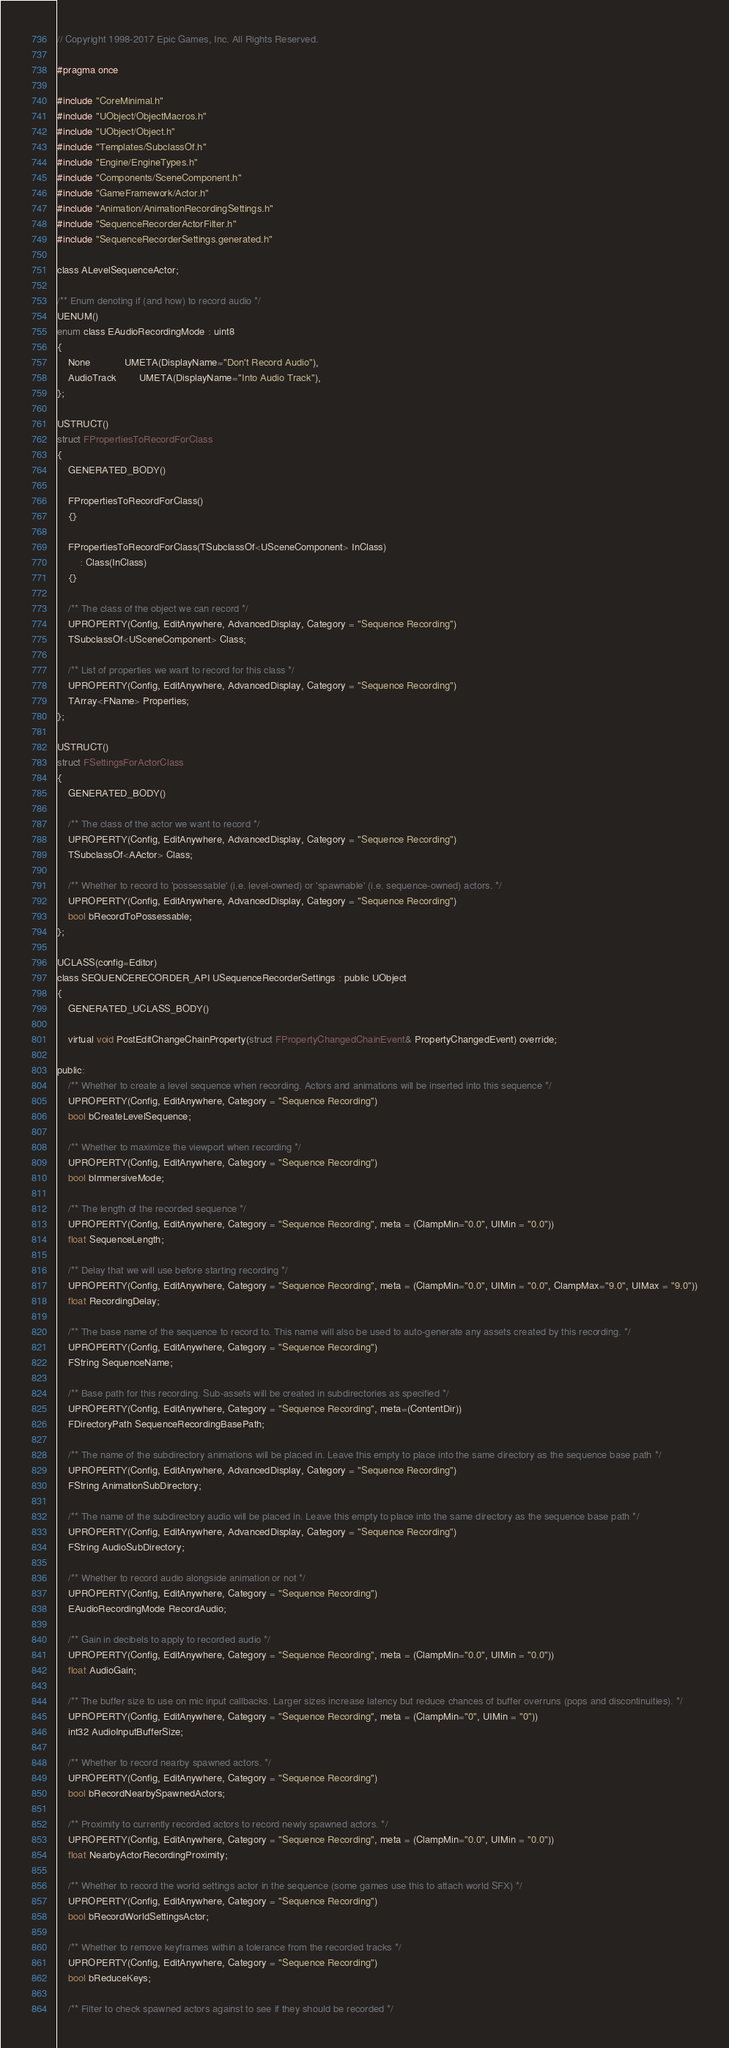<code> <loc_0><loc_0><loc_500><loc_500><_C_>// Copyright 1998-2017 Epic Games, Inc. All Rights Reserved.

#pragma once

#include "CoreMinimal.h"
#include "UObject/ObjectMacros.h"
#include "UObject/Object.h"
#include "Templates/SubclassOf.h"
#include "Engine/EngineTypes.h"
#include "Components/SceneComponent.h"
#include "GameFramework/Actor.h"
#include "Animation/AnimationRecordingSettings.h"
#include "SequenceRecorderActorFilter.h"
#include "SequenceRecorderSettings.generated.h"

class ALevelSequenceActor;

/** Enum denoting if (and how) to record audio */
UENUM()
enum class EAudioRecordingMode : uint8
{
	None 			UMETA(DisplayName="Don't Record Audio"),
	AudioTrack		UMETA(DisplayName="Into Audio Track"),
};

USTRUCT()
struct FPropertiesToRecordForClass
{
	GENERATED_BODY()

	FPropertiesToRecordForClass()
	{}

	FPropertiesToRecordForClass(TSubclassOf<USceneComponent> InClass)
		: Class(InClass)
	{}

	/** The class of the object we can record */
	UPROPERTY(Config, EditAnywhere, AdvancedDisplay, Category = "Sequence Recording")
	TSubclassOf<USceneComponent> Class;

	/** List of properties we want to record for this class */
	UPROPERTY(Config, EditAnywhere, AdvancedDisplay, Category = "Sequence Recording")
	TArray<FName> Properties;
};

USTRUCT()
struct FSettingsForActorClass
{
	GENERATED_BODY()

	/** The class of the actor we want to record */
	UPROPERTY(Config, EditAnywhere, AdvancedDisplay, Category = "Sequence Recording")
	TSubclassOf<AActor> Class;

	/** Whether to record to 'possessable' (i.e. level-owned) or 'spawnable' (i.e. sequence-owned) actors. */
	UPROPERTY(Config, EditAnywhere, AdvancedDisplay, Category = "Sequence Recording")
	bool bRecordToPossessable;
};

UCLASS(config=Editor)
class SEQUENCERECORDER_API USequenceRecorderSettings : public UObject
{
	GENERATED_UCLASS_BODY()

	virtual void PostEditChangeChainProperty(struct FPropertyChangedChainEvent& PropertyChangedEvent) override;

public:
	/** Whether to create a level sequence when recording. Actors and animations will be inserted into this sequence */
	UPROPERTY(Config, EditAnywhere, Category = "Sequence Recording")
	bool bCreateLevelSequence;

	/** Whether to maximize the viewport when recording */
	UPROPERTY(Config, EditAnywhere, Category = "Sequence Recording")
	bool bImmersiveMode;

	/** The length of the recorded sequence */
	UPROPERTY(Config, EditAnywhere, Category = "Sequence Recording", meta = (ClampMin="0.0", UIMin = "0.0"))
	float SequenceLength;

	/** Delay that we will use before starting recording */
	UPROPERTY(Config, EditAnywhere, Category = "Sequence Recording", meta = (ClampMin="0.0", UIMin = "0.0", ClampMax="9.0", UIMax = "9.0"))
	float RecordingDelay;

	/** The base name of the sequence to record to. This name will also be used to auto-generate any assets created by this recording. */
	UPROPERTY(Config, EditAnywhere, Category = "Sequence Recording")
	FString SequenceName;

	/** Base path for this recording. Sub-assets will be created in subdirectories as specified */
	UPROPERTY(Config, EditAnywhere, Category = "Sequence Recording", meta=(ContentDir))
	FDirectoryPath SequenceRecordingBasePath;

	/** The name of the subdirectory animations will be placed in. Leave this empty to place into the same directory as the sequence base path */
	UPROPERTY(Config, EditAnywhere, AdvancedDisplay, Category = "Sequence Recording")
	FString AnimationSubDirectory;

	/** The name of the subdirectory audio will be placed in. Leave this empty to place into the same directory as the sequence base path */
	UPROPERTY(Config, EditAnywhere, AdvancedDisplay, Category = "Sequence Recording")
	FString AudioSubDirectory;

	/** Whether to record audio alongside animation or not */
	UPROPERTY(Config, EditAnywhere, Category = "Sequence Recording")
	EAudioRecordingMode RecordAudio;

	/** Gain in decibels to apply to recorded audio */
	UPROPERTY(Config, EditAnywhere, Category = "Sequence Recording", meta = (ClampMin="0.0", UIMin = "0.0"))
	float AudioGain;

	/** The buffer size to use on mic input callbacks. Larger sizes increase latency but reduce chances of buffer overruns (pops and discontinuities). */
	UPROPERTY(Config, EditAnywhere, Category = "Sequence Recording", meta = (ClampMin="0", UIMin = "0"))
	int32 AudioInputBufferSize;

	/** Whether to record nearby spawned actors. */
	UPROPERTY(Config, EditAnywhere, Category = "Sequence Recording")
	bool bRecordNearbySpawnedActors;

	/** Proximity to currently recorded actors to record newly spawned actors. */
	UPROPERTY(Config, EditAnywhere, Category = "Sequence Recording", meta = (ClampMin="0.0", UIMin = "0.0"))
	float NearbyActorRecordingProximity;

	/** Whether to record the world settings actor in the sequence (some games use this to attach world SFX) */
	UPROPERTY(Config, EditAnywhere, Category = "Sequence Recording")
	bool bRecordWorldSettingsActor;

	/** Whether to remove keyframes within a tolerance from the recorded tracks */
	UPROPERTY(Config, EditAnywhere, Category = "Sequence Recording")
	bool bReduceKeys;

	/** Filter to check spawned actors against to see if they should be recorded */</code> 